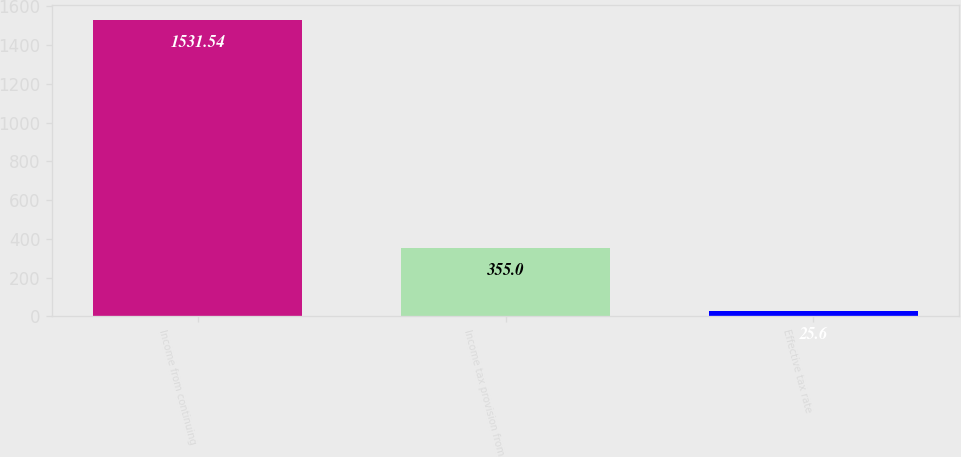Convert chart to OTSL. <chart><loc_0><loc_0><loc_500><loc_500><bar_chart><fcel>Income from continuing<fcel>Income tax provision from<fcel>Effective tax rate<nl><fcel>1531.54<fcel>355<fcel>25.6<nl></chart> 